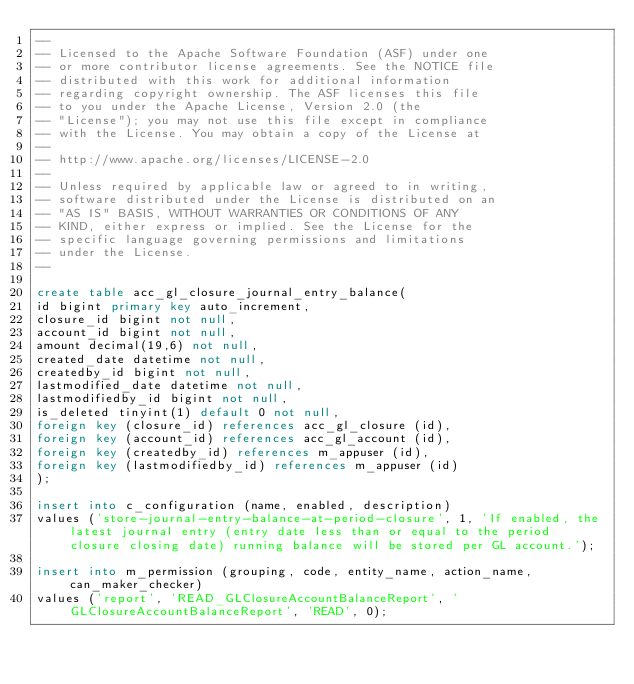Convert code to text. <code><loc_0><loc_0><loc_500><loc_500><_SQL_>--
-- Licensed to the Apache Software Foundation (ASF) under one
-- or more contributor license agreements. See the NOTICE file
-- distributed with this work for additional information
-- regarding copyright ownership. The ASF licenses this file
-- to you under the Apache License, Version 2.0 (the
-- "License"); you may not use this file except in compliance
-- with the License. You may obtain a copy of the License at
--
-- http://www.apache.org/licenses/LICENSE-2.0
--
-- Unless required by applicable law or agreed to in writing,
-- software distributed under the License is distributed on an
-- "AS IS" BASIS, WITHOUT WARRANTIES OR CONDITIONS OF ANY
-- KIND, either express or implied. See the License for the
-- specific language governing permissions and limitations
-- under the License.
--

create table acc_gl_closure_journal_entry_balance(
id bigint primary key auto_increment,
closure_id bigint not null,
account_id bigint not null,
amount decimal(19,6) not null,
created_date datetime not null,
createdby_id bigint not null,
lastmodified_date datetime not null,
lastmodifiedby_id bigint not null,
is_deleted tinyint(1) default 0 not null,
foreign key (closure_id) references acc_gl_closure (id),
foreign key (account_id) references acc_gl_account (id),
foreign key (createdby_id) references m_appuser (id),
foreign key (lastmodifiedby_id) references m_appuser (id)
);

insert into c_configuration (name, enabled, description)
values ('store-journal-entry-balance-at-period-closure', 1, 'If enabled, the latest journal entry (entry date less than or equal to the period closure closing date) running balance will be stored per GL account.');

insert into m_permission (grouping, code, entity_name, action_name, can_maker_checker)
values ('report', 'READ_GLClosureAccountBalanceReport', 'GLClosureAccountBalanceReport', 'READ', 0);</code> 